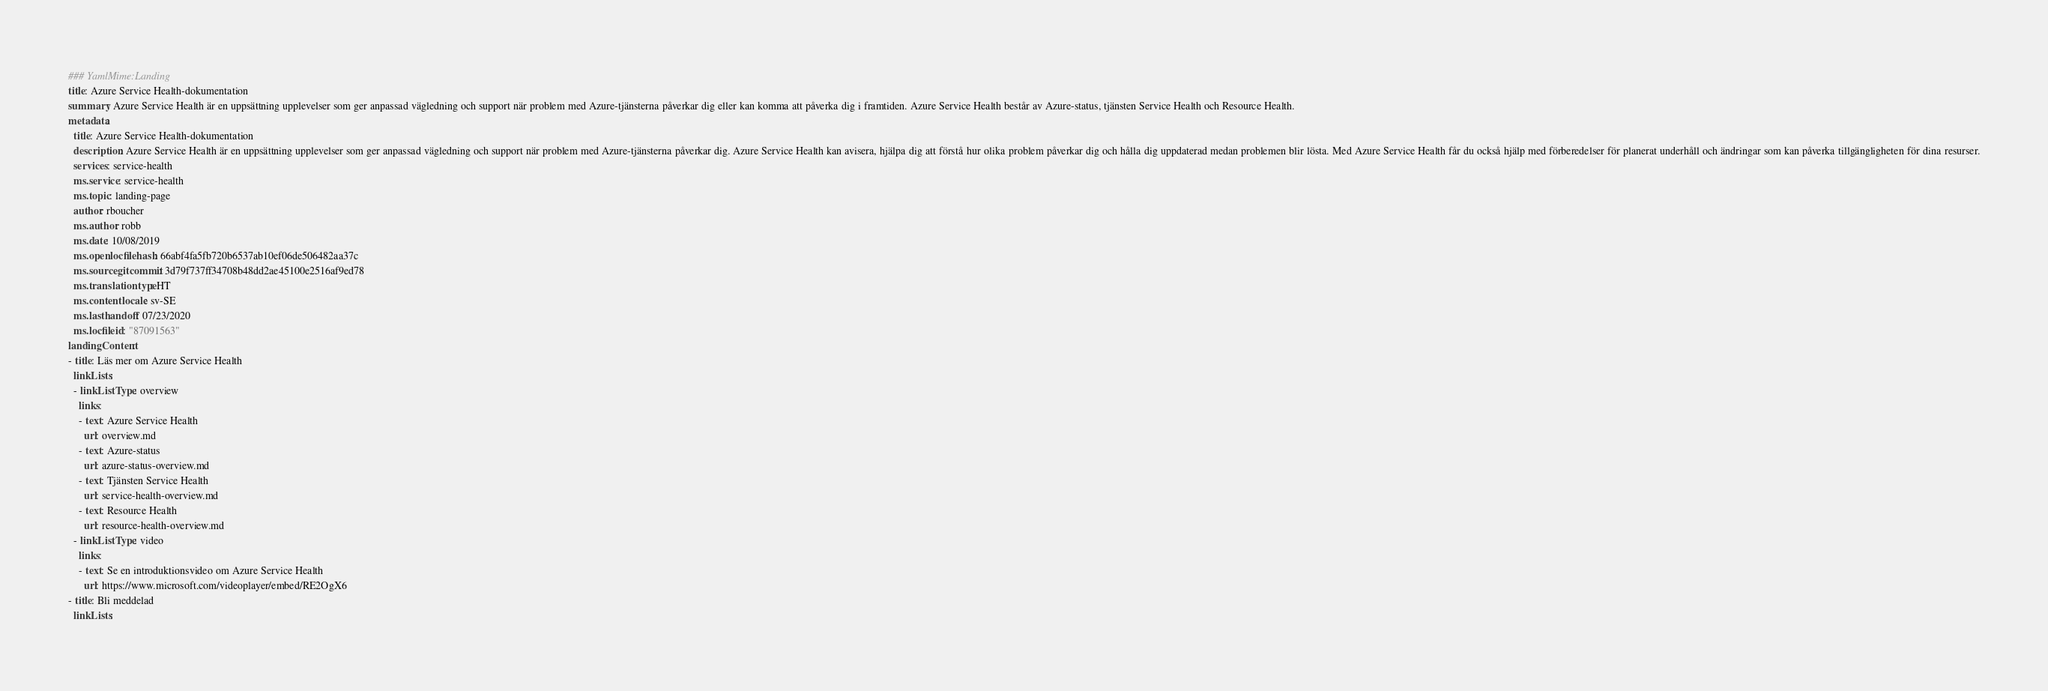Convert code to text. <code><loc_0><loc_0><loc_500><loc_500><_YAML_>### YamlMime:Landing
title: Azure Service Health-dokumentation
summary: Azure Service Health är en uppsättning upplevelser som ger anpassad vägledning och support när problem med Azure-tjänsterna påverkar dig eller kan komma att påverka dig i framtiden. Azure Service Health består av Azure-status, tjänsten Service Health och Resource Health.
metadata:
  title: Azure Service Health-dokumentation
  description: Azure Service Health är en uppsättning upplevelser som ger anpassad vägledning och support när problem med Azure-tjänsterna påverkar dig. Azure Service Health kan avisera, hjälpa dig att förstå hur olika problem påverkar dig och hålla dig uppdaterad medan problemen blir lösta. Med Azure Service Health får du också hjälp med förberedelser för planerat underhåll och ändringar som kan påverka tillgängligheten för dina resurser.
  services: service-health
  ms.service: service-health
  ms.topic: landing-page
  author: rboucher
  ms.author: robb
  ms.date: 10/08/2019
  ms.openlocfilehash: 66abf4fa5fb720b6537ab10ef06de506482aa37c
  ms.sourcegitcommit: 3d79f737ff34708b48dd2ae45100e2516af9ed78
  ms.translationtype: HT
  ms.contentlocale: sv-SE
  ms.lasthandoff: 07/23/2020
  ms.locfileid: "87091563"
landingContent:
- title: Läs mer om Azure Service Health
  linkLists:
  - linkListType: overview
    links:
    - text: Azure Service Health
      url: overview.md
    - text: Azure-status
      url: azure-status-overview.md
    - text: Tjänsten Service Health
      url: service-health-overview.md
    - text: Resource Health
      url: resource-health-overview.md
  - linkListType: video
    links:
    - text: Se en introduktionsvideo om Azure Service Health
      url: https://www.microsoft.com/videoplayer/embed/RE2OgX6
- title: Bli meddelad
  linkLists:</code> 